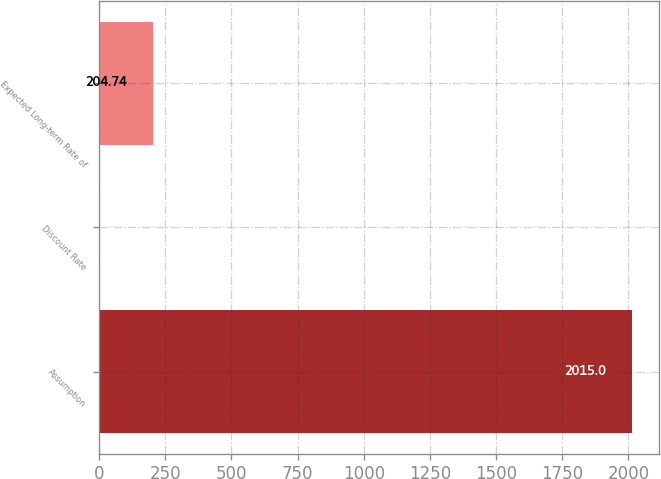Convert chart to OTSL. <chart><loc_0><loc_0><loc_500><loc_500><bar_chart><fcel>Assumption<fcel>Discount Rate<fcel>Expected Long-term Rate of<nl><fcel>2015<fcel>3.6<fcel>204.74<nl></chart> 